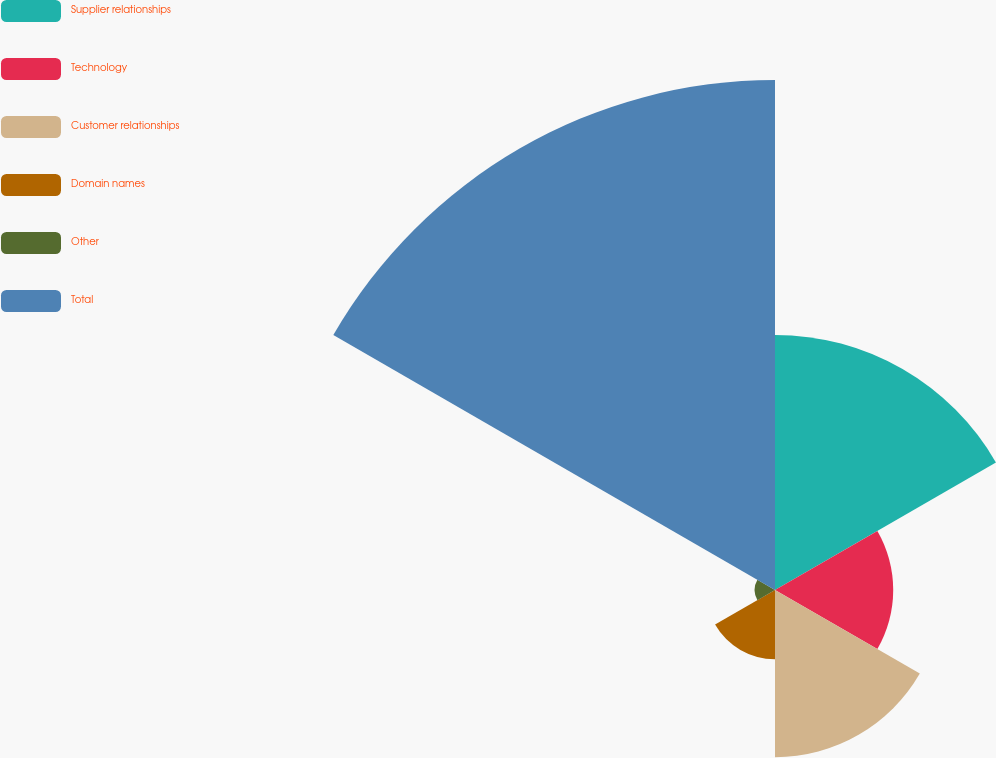Convert chart. <chart><loc_0><loc_0><loc_500><loc_500><pie_chart><fcel>Supplier relationships<fcel>Technology<fcel>Customer relationships<fcel>Domain names<fcel>Other<fcel>Total<nl><fcel>22.38%<fcel>10.37%<fcel>14.67%<fcel>6.07%<fcel>1.78%<fcel>44.74%<nl></chart> 